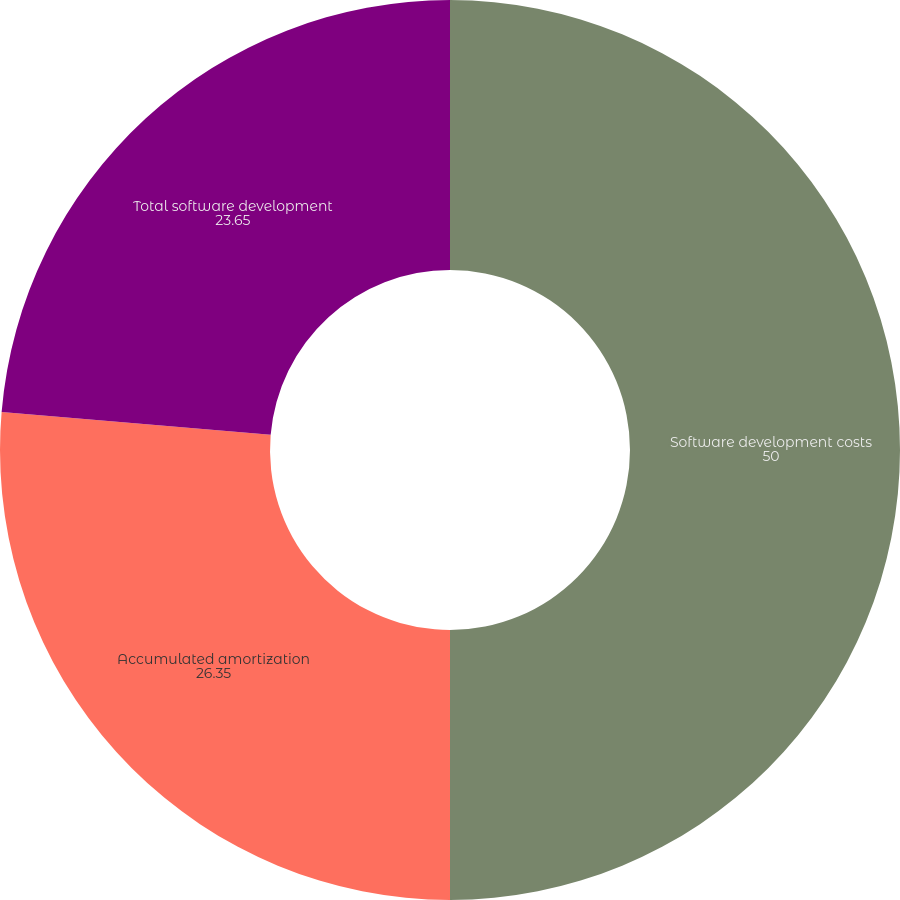<chart> <loc_0><loc_0><loc_500><loc_500><pie_chart><fcel>Software development costs<fcel>Accumulated amortization<fcel>Total software development<nl><fcel>50.0%<fcel>26.35%<fcel>23.65%<nl></chart> 